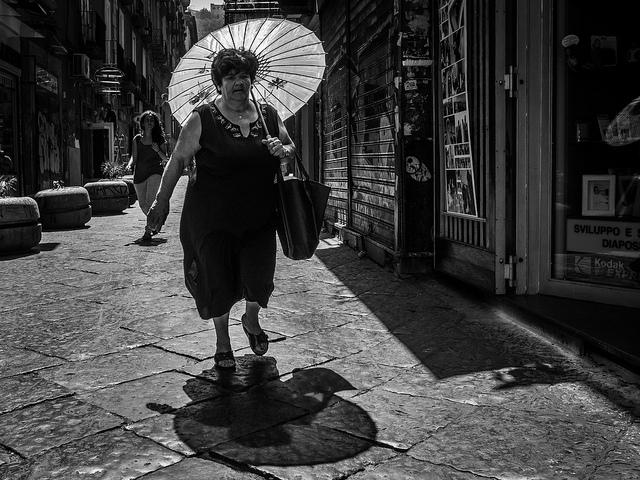Is the image in black and white?
Short answer required. Yes. What year was this picture taken?
Concise answer only. 1990. Does the woman appear to use the umbrella to shield herself from sun or rain?
Give a very brief answer. Sun. 